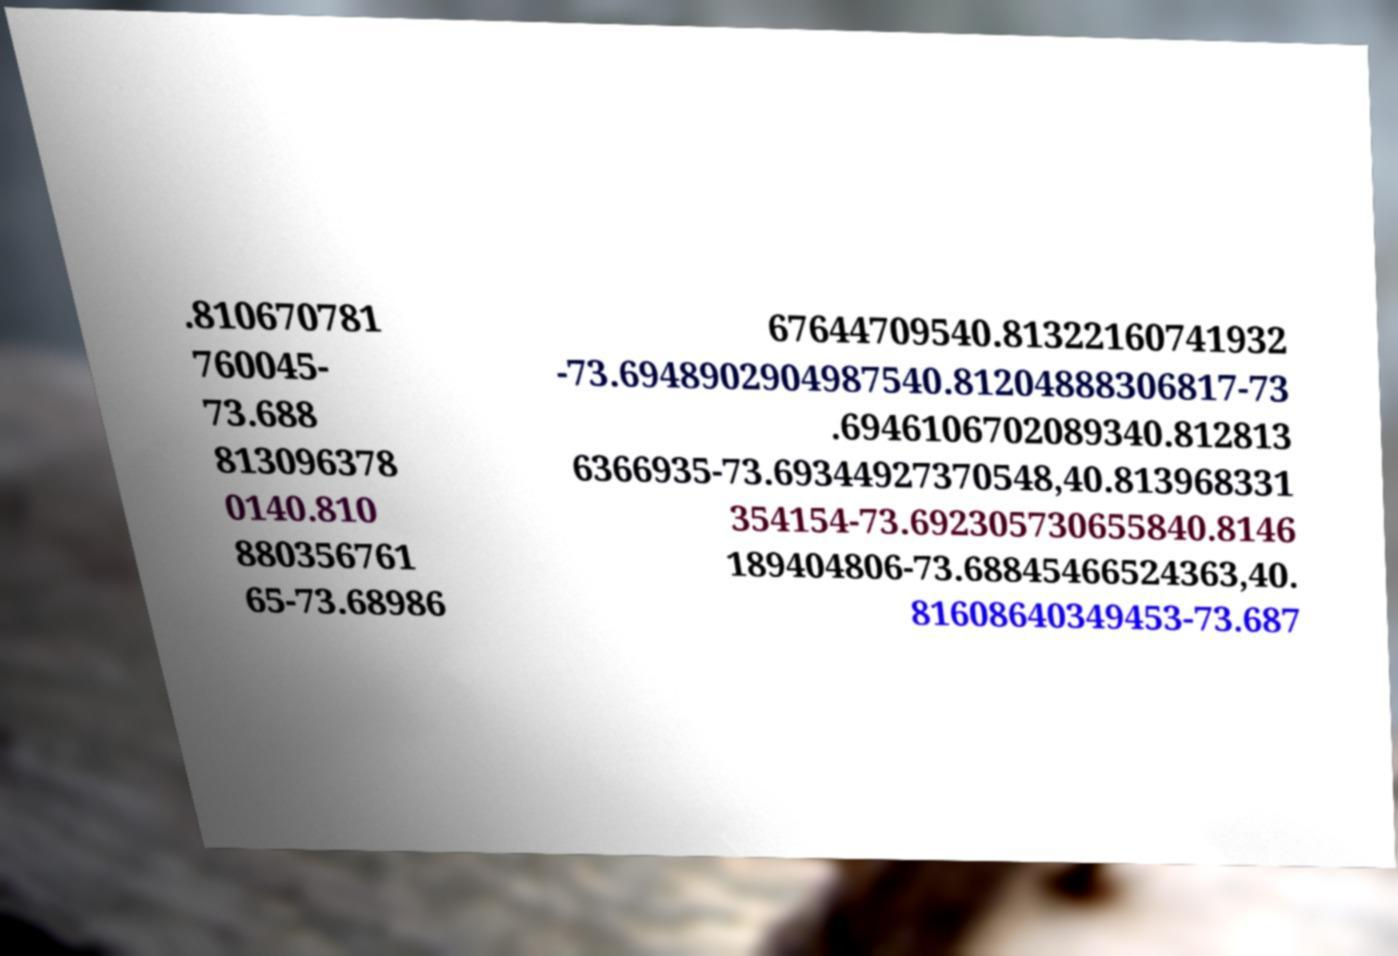Please read and relay the text visible in this image. What does it say? .810670781 760045- 73.688 813096378 0140.810 880356761 65-73.68986 67644709540.81322160741932 -73.6948902904987540.81204888306817-73 .6946106702089340.812813 6366935-73.69344927370548,40.813968331 354154-73.692305730655840.8146 189404806-73.68845466524363,40. 81608640349453-73.687 